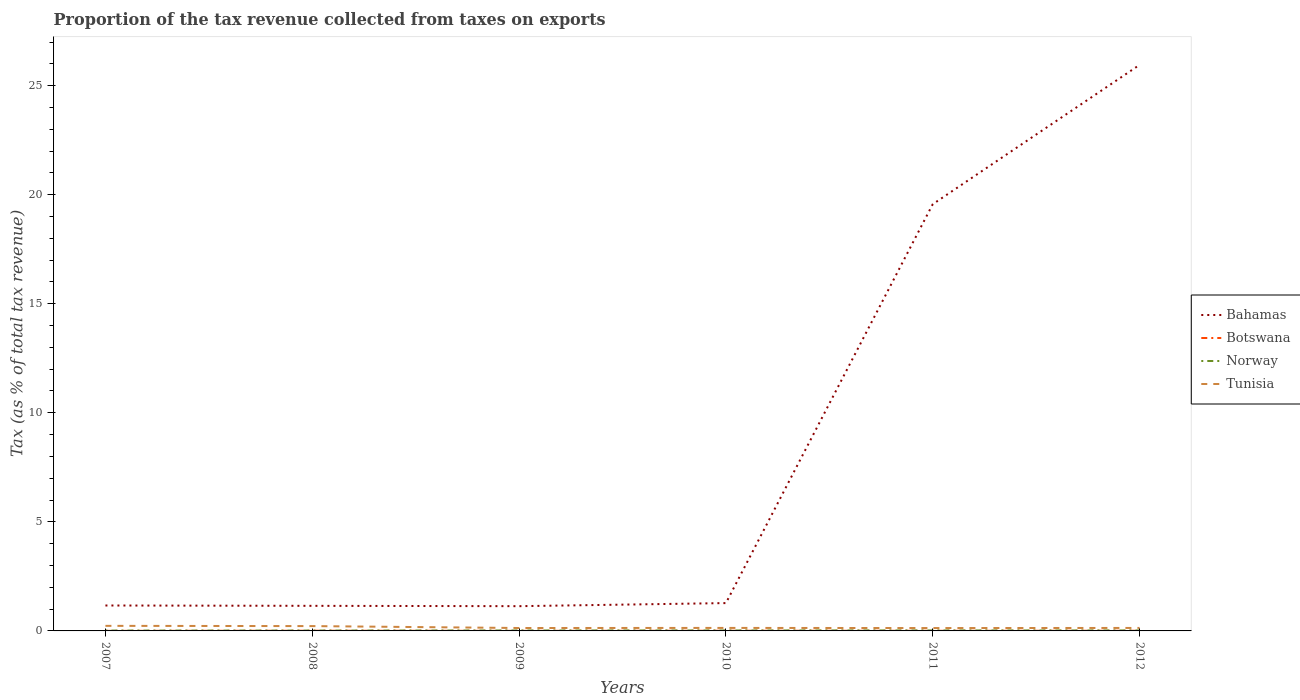Does the line corresponding to Norway intersect with the line corresponding to Bahamas?
Provide a succinct answer. No. Is the number of lines equal to the number of legend labels?
Keep it short and to the point. Yes. Across all years, what is the maximum proportion of the tax revenue collected in Bahamas?
Provide a succinct answer. 1.13. What is the total proportion of the tax revenue collected in Norway in the graph?
Keep it short and to the point. -0. What is the difference between the highest and the second highest proportion of the tax revenue collected in Bahamas?
Give a very brief answer. 24.82. What is the difference between the highest and the lowest proportion of the tax revenue collected in Botswana?
Your answer should be very brief. 3. Is the proportion of the tax revenue collected in Norway strictly greater than the proportion of the tax revenue collected in Botswana over the years?
Ensure brevity in your answer.  No. How many lines are there?
Make the answer very short. 4. Does the graph contain grids?
Make the answer very short. No. Where does the legend appear in the graph?
Your response must be concise. Center right. What is the title of the graph?
Your answer should be very brief. Proportion of the tax revenue collected from taxes on exports. Does "Ireland" appear as one of the legend labels in the graph?
Ensure brevity in your answer.  No. What is the label or title of the Y-axis?
Give a very brief answer. Tax (as % of total tax revenue). What is the Tax (as % of total tax revenue) of Bahamas in 2007?
Provide a succinct answer. 1.17. What is the Tax (as % of total tax revenue) of Botswana in 2007?
Your answer should be very brief. 0. What is the Tax (as % of total tax revenue) of Norway in 2007?
Offer a terse response. 0.02. What is the Tax (as % of total tax revenue) of Tunisia in 2007?
Provide a short and direct response. 0.23. What is the Tax (as % of total tax revenue) in Bahamas in 2008?
Offer a terse response. 1.15. What is the Tax (as % of total tax revenue) of Botswana in 2008?
Ensure brevity in your answer.  0.01. What is the Tax (as % of total tax revenue) in Norway in 2008?
Your answer should be compact. 0.02. What is the Tax (as % of total tax revenue) in Tunisia in 2008?
Provide a succinct answer. 0.22. What is the Tax (as % of total tax revenue) in Bahamas in 2009?
Make the answer very short. 1.13. What is the Tax (as % of total tax revenue) of Botswana in 2009?
Offer a terse response. 0. What is the Tax (as % of total tax revenue) of Norway in 2009?
Give a very brief answer. 0.02. What is the Tax (as % of total tax revenue) of Tunisia in 2009?
Offer a very short reply. 0.13. What is the Tax (as % of total tax revenue) in Bahamas in 2010?
Your answer should be very brief. 1.28. What is the Tax (as % of total tax revenue) of Botswana in 2010?
Provide a succinct answer. 0.01. What is the Tax (as % of total tax revenue) of Norway in 2010?
Ensure brevity in your answer.  0.02. What is the Tax (as % of total tax revenue) of Tunisia in 2010?
Your answer should be very brief. 0.14. What is the Tax (as % of total tax revenue) of Bahamas in 2011?
Ensure brevity in your answer.  19.56. What is the Tax (as % of total tax revenue) in Botswana in 2011?
Provide a short and direct response. 0.01. What is the Tax (as % of total tax revenue) in Norway in 2011?
Keep it short and to the point. 0.02. What is the Tax (as % of total tax revenue) of Tunisia in 2011?
Make the answer very short. 0.13. What is the Tax (as % of total tax revenue) in Bahamas in 2012?
Ensure brevity in your answer.  25.95. What is the Tax (as % of total tax revenue) in Botswana in 2012?
Offer a very short reply. 0.01. What is the Tax (as % of total tax revenue) in Norway in 2012?
Offer a terse response. 0.02. What is the Tax (as % of total tax revenue) of Tunisia in 2012?
Keep it short and to the point. 0.14. Across all years, what is the maximum Tax (as % of total tax revenue) in Bahamas?
Give a very brief answer. 25.95. Across all years, what is the maximum Tax (as % of total tax revenue) in Botswana?
Your response must be concise. 0.01. Across all years, what is the maximum Tax (as % of total tax revenue) of Norway?
Offer a terse response. 0.02. Across all years, what is the maximum Tax (as % of total tax revenue) of Tunisia?
Provide a short and direct response. 0.23. Across all years, what is the minimum Tax (as % of total tax revenue) of Bahamas?
Provide a succinct answer. 1.13. Across all years, what is the minimum Tax (as % of total tax revenue) in Botswana?
Offer a terse response. 0. Across all years, what is the minimum Tax (as % of total tax revenue) of Norway?
Your response must be concise. 0.02. Across all years, what is the minimum Tax (as % of total tax revenue) in Tunisia?
Provide a succinct answer. 0.13. What is the total Tax (as % of total tax revenue) in Bahamas in the graph?
Provide a succinct answer. 50.24. What is the total Tax (as % of total tax revenue) of Botswana in the graph?
Provide a short and direct response. 0.04. What is the total Tax (as % of total tax revenue) in Norway in the graph?
Keep it short and to the point. 0.12. What is the difference between the Tax (as % of total tax revenue) in Bahamas in 2007 and that in 2008?
Offer a very short reply. 0.02. What is the difference between the Tax (as % of total tax revenue) in Botswana in 2007 and that in 2008?
Provide a short and direct response. -0.01. What is the difference between the Tax (as % of total tax revenue) in Norway in 2007 and that in 2008?
Offer a terse response. 0. What is the difference between the Tax (as % of total tax revenue) in Tunisia in 2007 and that in 2008?
Your answer should be compact. 0.01. What is the difference between the Tax (as % of total tax revenue) in Bahamas in 2007 and that in 2009?
Your answer should be compact. 0.03. What is the difference between the Tax (as % of total tax revenue) in Botswana in 2007 and that in 2009?
Provide a short and direct response. -0. What is the difference between the Tax (as % of total tax revenue) in Norway in 2007 and that in 2009?
Your response must be concise. -0. What is the difference between the Tax (as % of total tax revenue) of Tunisia in 2007 and that in 2009?
Offer a very short reply. 0.1. What is the difference between the Tax (as % of total tax revenue) in Bahamas in 2007 and that in 2010?
Your answer should be compact. -0.11. What is the difference between the Tax (as % of total tax revenue) of Botswana in 2007 and that in 2010?
Give a very brief answer. -0.01. What is the difference between the Tax (as % of total tax revenue) in Norway in 2007 and that in 2010?
Ensure brevity in your answer.  -0.01. What is the difference between the Tax (as % of total tax revenue) of Tunisia in 2007 and that in 2010?
Ensure brevity in your answer.  0.09. What is the difference between the Tax (as % of total tax revenue) of Bahamas in 2007 and that in 2011?
Offer a very short reply. -18.4. What is the difference between the Tax (as % of total tax revenue) in Botswana in 2007 and that in 2011?
Provide a succinct answer. -0. What is the difference between the Tax (as % of total tax revenue) of Norway in 2007 and that in 2011?
Give a very brief answer. -0.01. What is the difference between the Tax (as % of total tax revenue) of Tunisia in 2007 and that in 2011?
Your response must be concise. 0.1. What is the difference between the Tax (as % of total tax revenue) of Bahamas in 2007 and that in 2012?
Your response must be concise. -24.79. What is the difference between the Tax (as % of total tax revenue) in Botswana in 2007 and that in 2012?
Your response must be concise. -0.01. What is the difference between the Tax (as % of total tax revenue) in Norway in 2007 and that in 2012?
Your response must be concise. -0. What is the difference between the Tax (as % of total tax revenue) of Tunisia in 2007 and that in 2012?
Ensure brevity in your answer.  0.1. What is the difference between the Tax (as % of total tax revenue) in Bahamas in 2008 and that in 2009?
Your answer should be compact. 0.02. What is the difference between the Tax (as % of total tax revenue) in Botswana in 2008 and that in 2009?
Give a very brief answer. 0. What is the difference between the Tax (as % of total tax revenue) in Norway in 2008 and that in 2009?
Ensure brevity in your answer.  -0. What is the difference between the Tax (as % of total tax revenue) in Tunisia in 2008 and that in 2009?
Your response must be concise. 0.09. What is the difference between the Tax (as % of total tax revenue) of Bahamas in 2008 and that in 2010?
Provide a succinct answer. -0.13. What is the difference between the Tax (as % of total tax revenue) of Botswana in 2008 and that in 2010?
Keep it short and to the point. -0. What is the difference between the Tax (as % of total tax revenue) of Norway in 2008 and that in 2010?
Make the answer very short. -0.01. What is the difference between the Tax (as % of total tax revenue) in Tunisia in 2008 and that in 2010?
Your answer should be very brief. 0.08. What is the difference between the Tax (as % of total tax revenue) in Bahamas in 2008 and that in 2011?
Your response must be concise. -18.41. What is the difference between the Tax (as % of total tax revenue) in Botswana in 2008 and that in 2011?
Provide a succinct answer. 0. What is the difference between the Tax (as % of total tax revenue) in Norway in 2008 and that in 2011?
Your answer should be compact. -0.01. What is the difference between the Tax (as % of total tax revenue) of Tunisia in 2008 and that in 2011?
Provide a succinct answer. 0.09. What is the difference between the Tax (as % of total tax revenue) of Bahamas in 2008 and that in 2012?
Offer a terse response. -24.8. What is the difference between the Tax (as % of total tax revenue) of Botswana in 2008 and that in 2012?
Your answer should be compact. 0. What is the difference between the Tax (as % of total tax revenue) in Norway in 2008 and that in 2012?
Your answer should be very brief. -0. What is the difference between the Tax (as % of total tax revenue) in Tunisia in 2008 and that in 2012?
Your answer should be very brief. 0.09. What is the difference between the Tax (as % of total tax revenue) of Bahamas in 2009 and that in 2010?
Make the answer very short. -0.14. What is the difference between the Tax (as % of total tax revenue) of Botswana in 2009 and that in 2010?
Keep it short and to the point. -0. What is the difference between the Tax (as % of total tax revenue) of Norway in 2009 and that in 2010?
Ensure brevity in your answer.  -0. What is the difference between the Tax (as % of total tax revenue) of Tunisia in 2009 and that in 2010?
Your answer should be very brief. -0. What is the difference between the Tax (as % of total tax revenue) of Bahamas in 2009 and that in 2011?
Make the answer very short. -18.43. What is the difference between the Tax (as % of total tax revenue) of Botswana in 2009 and that in 2011?
Your answer should be compact. -0. What is the difference between the Tax (as % of total tax revenue) of Norway in 2009 and that in 2011?
Make the answer very short. -0. What is the difference between the Tax (as % of total tax revenue) in Tunisia in 2009 and that in 2011?
Provide a short and direct response. 0. What is the difference between the Tax (as % of total tax revenue) in Bahamas in 2009 and that in 2012?
Offer a very short reply. -24.82. What is the difference between the Tax (as % of total tax revenue) in Botswana in 2009 and that in 2012?
Make the answer very short. -0. What is the difference between the Tax (as % of total tax revenue) in Norway in 2009 and that in 2012?
Make the answer very short. -0. What is the difference between the Tax (as % of total tax revenue) of Tunisia in 2009 and that in 2012?
Your answer should be very brief. -0. What is the difference between the Tax (as % of total tax revenue) in Bahamas in 2010 and that in 2011?
Keep it short and to the point. -18.29. What is the difference between the Tax (as % of total tax revenue) in Botswana in 2010 and that in 2011?
Make the answer very short. 0. What is the difference between the Tax (as % of total tax revenue) of Norway in 2010 and that in 2011?
Your answer should be compact. -0. What is the difference between the Tax (as % of total tax revenue) in Tunisia in 2010 and that in 2011?
Make the answer very short. 0.01. What is the difference between the Tax (as % of total tax revenue) in Bahamas in 2010 and that in 2012?
Provide a short and direct response. -24.68. What is the difference between the Tax (as % of total tax revenue) in Botswana in 2010 and that in 2012?
Provide a short and direct response. 0. What is the difference between the Tax (as % of total tax revenue) of Norway in 2010 and that in 2012?
Your response must be concise. 0. What is the difference between the Tax (as % of total tax revenue) of Tunisia in 2010 and that in 2012?
Your answer should be compact. 0. What is the difference between the Tax (as % of total tax revenue) of Bahamas in 2011 and that in 2012?
Your answer should be compact. -6.39. What is the difference between the Tax (as % of total tax revenue) in Botswana in 2011 and that in 2012?
Your response must be concise. -0. What is the difference between the Tax (as % of total tax revenue) of Norway in 2011 and that in 2012?
Make the answer very short. 0. What is the difference between the Tax (as % of total tax revenue) in Tunisia in 2011 and that in 2012?
Your response must be concise. -0. What is the difference between the Tax (as % of total tax revenue) of Bahamas in 2007 and the Tax (as % of total tax revenue) of Botswana in 2008?
Give a very brief answer. 1.16. What is the difference between the Tax (as % of total tax revenue) of Bahamas in 2007 and the Tax (as % of total tax revenue) of Norway in 2008?
Your answer should be compact. 1.15. What is the difference between the Tax (as % of total tax revenue) in Bahamas in 2007 and the Tax (as % of total tax revenue) in Tunisia in 2008?
Ensure brevity in your answer.  0.94. What is the difference between the Tax (as % of total tax revenue) of Botswana in 2007 and the Tax (as % of total tax revenue) of Norway in 2008?
Make the answer very short. -0.01. What is the difference between the Tax (as % of total tax revenue) in Botswana in 2007 and the Tax (as % of total tax revenue) in Tunisia in 2008?
Your answer should be very brief. -0.22. What is the difference between the Tax (as % of total tax revenue) of Norway in 2007 and the Tax (as % of total tax revenue) of Tunisia in 2008?
Your response must be concise. -0.2. What is the difference between the Tax (as % of total tax revenue) of Bahamas in 2007 and the Tax (as % of total tax revenue) of Botswana in 2009?
Provide a short and direct response. 1.16. What is the difference between the Tax (as % of total tax revenue) in Bahamas in 2007 and the Tax (as % of total tax revenue) in Norway in 2009?
Your answer should be compact. 1.15. What is the difference between the Tax (as % of total tax revenue) in Bahamas in 2007 and the Tax (as % of total tax revenue) in Tunisia in 2009?
Offer a very short reply. 1.03. What is the difference between the Tax (as % of total tax revenue) of Botswana in 2007 and the Tax (as % of total tax revenue) of Norway in 2009?
Offer a very short reply. -0.02. What is the difference between the Tax (as % of total tax revenue) in Botswana in 2007 and the Tax (as % of total tax revenue) in Tunisia in 2009?
Your answer should be very brief. -0.13. What is the difference between the Tax (as % of total tax revenue) of Norway in 2007 and the Tax (as % of total tax revenue) of Tunisia in 2009?
Offer a terse response. -0.12. What is the difference between the Tax (as % of total tax revenue) of Bahamas in 2007 and the Tax (as % of total tax revenue) of Botswana in 2010?
Offer a terse response. 1.16. What is the difference between the Tax (as % of total tax revenue) in Bahamas in 2007 and the Tax (as % of total tax revenue) in Norway in 2010?
Make the answer very short. 1.14. What is the difference between the Tax (as % of total tax revenue) of Bahamas in 2007 and the Tax (as % of total tax revenue) of Tunisia in 2010?
Give a very brief answer. 1.03. What is the difference between the Tax (as % of total tax revenue) of Botswana in 2007 and the Tax (as % of total tax revenue) of Norway in 2010?
Keep it short and to the point. -0.02. What is the difference between the Tax (as % of total tax revenue) of Botswana in 2007 and the Tax (as % of total tax revenue) of Tunisia in 2010?
Give a very brief answer. -0.14. What is the difference between the Tax (as % of total tax revenue) in Norway in 2007 and the Tax (as % of total tax revenue) in Tunisia in 2010?
Your answer should be very brief. -0.12. What is the difference between the Tax (as % of total tax revenue) in Bahamas in 2007 and the Tax (as % of total tax revenue) in Botswana in 2011?
Provide a succinct answer. 1.16. What is the difference between the Tax (as % of total tax revenue) of Bahamas in 2007 and the Tax (as % of total tax revenue) of Norway in 2011?
Give a very brief answer. 1.14. What is the difference between the Tax (as % of total tax revenue) of Bahamas in 2007 and the Tax (as % of total tax revenue) of Tunisia in 2011?
Offer a very short reply. 1.03. What is the difference between the Tax (as % of total tax revenue) of Botswana in 2007 and the Tax (as % of total tax revenue) of Norway in 2011?
Your answer should be compact. -0.02. What is the difference between the Tax (as % of total tax revenue) in Botswana in 2007 and the Tax (as % of total tax revenue) in Tunisia in 2011?
Offer a very short reply. -0.13. What is the difference between the Tax (as % of total tax revenue) of Norway in 2007 and the Tax (as % of total tax revenue) of Tunisia in 2011?
Provide a short and direct response. -0.12. What is the difference between the Tax (as % of total tax revenue) of Bahamas in 2007 and the Tax (as % of total tax revenue) of Botswana in 2012?
Provide a short and direct response. 1.16. What is the difference between the Tax (as % of total tax revenue) of Bahamas in 2007 and the Tax (as % of total tax revenue) of Norway in 2012?
Make the answer very short. 1.14. What is the difference between the Tax (as % of total tax revenue) in Bahamas in 2007 and the Tax (as % of total tax revenue) in Tunisia in 2012?
Offer a terse response. 1.03. What is the difference between the Tax (as % of total tax revenue) of Botswana in 2007 and the Tax (as % of total tax revenue) of Norway in 2012?
Your answer should be very brief. -0.02. What is the difference between the Tax (as % of total tax revenue) of Botswana in 2007 and the Tax (as % of total tax revenue) of Tunisia in 2012?
Provide a succinct answer. -0.13. What is the difference between the Tax (as % of total tax revenue) in Norway in 2007 and the Tax (as % of total tax revenue) in Tunisia in 2012?
Your response must be concise. -0.12. What is the difference between the Tax (as % of total tax revenue) of Bahamas in 2008 and the Tax (as % of total tax revenue) of Botswana in 2009?
Offer a very short reply. 1.15. What is the difference between the Tax (as % of total tax revenue) in Bahamas in 2008 and the Tax (as % of total tax revenue) in Norway in 2009?
Offer a terse response. 1.13. What is the difference between the Tax (as % of total tax revenue) of Bahamas in 2008 and the Tax (as % of total tax revenue) of Tunisia in 2009?
Provide a short and direct response. 1.02. What is the difference between the Tax (as % of total tax revenue) of Botswana in 2008 and the Tax (as % of total tax revenue) of Norway in 2009?
Your response must be concise. -0.01. What is the difference between the Tax (as % of total tax revenue) in Botswana in 2008 and the Tax (as % of total tax revenue) in Tunisia in 2009?
Provide a succinct answer. -0.13. What is the difference between the Tax (as % of total tax revenue) of Norway in 2008 and the Tax (as % of total tax revenue) of Tunisia in 2009?
Provide a short and direct response. -0.12. What is the difference between the Tax (as % of total tax revenue) in Bahamas in 2008 and the Tax (as % of total tax revenue) in Botswana in 2010?
Ensure brevity in your answer.  1.14. What is the difference between the Tax (as % of total tax revenue) in Bahamas in 2008 and the Tax (as % of total tax revenue) in Norway in 2010?
Provide a short and direct response. 1.13. What is the difference between the Tax (as % of total tax revenue) in Bahamas in 2008 and the Tax (as % of total tax revenue) in Tunisia in 2010?
Make the answer very short. 1.01. What is the difference between the Tax (as % of total tax revenue) of Botswana in 2008 and the Tax (as % of total tax revenue) of Norway in 2010?
Make the answer very short. -0.01. What is the difference between the Tax (as % of total tax revenue) in Botswana in 2008 and the Tax (as % of total tax revenue) in Tunisia in 2010?
Provide a short and direct response. -0.13. What is the difference between the Tax (as % of total tax revenue) of Norway in 2008 and the Tax (as % of total tax revenue) of Tunisia in 2010?
Provide a succinct answer. -0.12. What is the difference between the Tax (as % of total tax revenue) of Bahamas in 2008 and the Tax (as % of total tax revenue) of Botswana in 2011?
Provide a short and direct response. 1.14. What is the difference between the Tax (as % of total tax revenue) in Bahamas in 2008 and the Tax (as % of total tax revenue) in Norway in 2011?
Give a very brief answer. 1.13. What is the difference between the Tax (as % of total tax revenue) in Bahamas in 2008 and the Tax (as % of total tax revenue) in Tunisia in 2011?
Make the answer very short. 1.02. What is the difference between the Tax (as % of total tax revenue) in Botswana in 2008 and the Tax (as % of total tax revenue) in Norway in 2011?
Ensure brevity in your answer.  -0.01. What is the difference between the Tax (as % of total tax revenue) in Botswana in 2008 and the Tax (as % of total tax revenue) in Tunisia in 2011?
Keep it short and to the point. -0.12. What is the difference between the Tax (as % of total tax revenue) in Norway in 2008 and the Tax (as % of total tax revenue) in Tunisia in 2011?
Give a very brief answer. -0.12. What is the difference between the Tax (as % of total tax revenue) in Bahamas in 2008 and the Tax (as % of total tax revenue) in Botswana in 2012?
Your response must be concise. 1.14. What is the difference between the Tax (as % of total tax revenue) in Bahamas in 2008 and the Tax (as % of total tax revenue) in Norway in 2012?
Your answer should be compact. 1.13. What is the difference between the Tax (as % of total tax revenue) in Bahamas in 2008 and the Tax (as % of total tax revenue) in Tunisia in 2012?
Offer a terse response. 1.01. What is the difference between the Tax (as % of total tax revenue) in Botswana in 2008 and the Tax (as % of total tax revenue) in Norway in 2012?
Give a very brief answer. -0.01. What is the difference between the Tax (as % of total tax revenue) of Botswana in 2008 and the Tax (as % of total tax revenue) of Tunisia in 2012?
Offer a very short reply. -0.13. What is the difference between the Tax (as % of total tax revenue) of Norway in 2008 and the Tax (as % of total tax revenue) of Tunisia in 2012?
Make the answer very short. -0.12. What is the difference between the Tax (as % of total tax revenue) of Bahamas in 2009 and the Tax (as % of total tax revenue) of Botswana in 2010?
Your answer should be compact. 1.13. What is the difference between the Tax (as % of total tax revenue) in Bahamas in 2009 and the Tax (as % of total tax revenue) in Norway in 2010?
Offer a terse response. 1.11. What is the difference between the Tax (as % of total tax revenue) of Bahamas in 2009 and the Tax (as % of total tax revenue) of Tunisia in 2010?
Offer a very short reply. 1. What is the difference between the Tax (as % of total tax revenue) in Botswana in 2009 and the Tax (as % of total tax revenue) in Norway in 2010?
Ensure brevity in your answer.  -0.02. What is the difference between the Tax (as % of total tax revenue) in Botswana in 2009 and the Tax (as % of total tax revenue) in Tunisia in 2010?
Make the answer very short. -0.13. What is the difference between the Tax (as % of total tax revenue) of Norway in 2009 and the Tax (as % of total tax revenue) of Tunisia in 2010?
Make the answer very short. -0.12. What is the difference between the Tax (as % of total tax revenue) of Bahamas in 2009 and the Tax (as % of total tax revenue) of Botswana in 2011?
Offer a very short reply. 1.13. What is the difference between the Tax (as % of total tax revenue) in Bahamas in 2009 and the Tax (as % of total tax revenue) in Norway in 2011?
Offer a very short reply. 1.11. What is the difference between the Tax (as % of total tax revenue) in Botswana in 2009 and the Tax (as % of total tax revenue) in Norway in 2011?
Keep it short and to the point. -0.02. What is the difference between the Tax (as % of total tax revenue) in Botswana in 2009 and the Tax (as % of total tax revenue) in Tunisia in 2011?
Your response must be concise. -0.13. What is the difference between the Tax (as % of total tax revenue) in Norway in 2009 and the Tax (as % of total tax revenue) in Tunisia in 2011?
Ensure brevity in your answer.  -0.11. What is the difference between the Tax (as % of total tax revenue) of Bahamas in 2009 and the Tax (as % of total tax revenue) of Botswana in 2012?
Provide a succinct answer. 1.13. What is the difference between the Tax (as % of total tax revenue) in Bahamas in 2009 and the Tax (as % of total tax revenue) in Norway in 2012?
Your answer should be compact. 1.11. What is the difference between the Tax (as % of total tax revenue) of Bahamas in 2009 and the Tax (as % of total tax revenue) of Tunisia in 2012?
Keep it short and to the point. 1. What is the difference between the Tax (as % of total tax revenue) of Botswana in 2009 and the Tax (as % of total tax revenue) of Norway in 2012?
Offer a very short reply. -0.02. What is the difference between the Tax (as % of total tax revenue) of Botswana in 2009 and the Tax (as % of total tax revenue) of Tunisia in 2012?
Give a very brief answer. -0.13. What is the difference between the Tax (as % of total tax revenue) of Norway in 2009 and the Tax (as % of total tax revenue) of Tunisia in 2012?
Provide a short and direct response. -0.12. What is the difference between the Tax (as % of total tax revenue) in Bahamas in 2010 and the Tax (as % of total tax revenue) in Botswana in 2011?
Give a very brief answer. 1.27. What is the difference between the Tax (as % of total tax revenue) in Bahamas in 2010 and the Tax (as % of total tax revenue) in Norway in 2011?
Provide a succinct answer. 1.25. What is the difference between the Tax (as % of total tax revenue) in Bahamas in 2010 and the Tax (as % of total tax revenue) in Tunisia in 2011?
Make the answer very short. 1.14. What is the difference between the Tax (as % of total tax revenue) of Botswana in 2010 and the Tax (as % of total tax revenue) of Norway in 2011?
Your response must be concise. -0.01. What is the difference between the Tax (as % of total tax revenue) in Botswana in 2010 and the Tax (as % of total tax revenue) in Tunisia in 2011?
Ensure brevity in your answer.  -0.12. What is the difference between the Tax (as % of total tax revenue) in Norway in 2010 and the Tax (as % of total tax revenue) in Tunisia in 2011?
Offer a very short reply. -0.11. What is the difference between the Tax (as % of total tax revenue) of Bahamas in 2010 and the Tax (as % of total tax revenue) of Botswana in 2012?
Offer a terse response. 1.27. What is the difference between the Tax (as % of total tax revenue) in Bahamas in 2010 and the Tax (as % of total tax revenue) in Norway in 2012?
Your response must be concise. 1.25. What is the difference between the Tax (as % of total tax revenue) in Bahamas in 2010 and the Tax (as % of total tax revenue) in Tunisia in 2012?
Your answer should be very brief. 1.14. What is the difference between the Tax (as % of total tax revenue) of Botswana in 2010 and the Tax (as % of total tax revenue) of Norway in 2012?
Your answer should be compact. -0.01. What is the difference between the Tax (as % of total tax revenue) in Botswana in 2010 and the Tax (as % of total tax revenue) in Tunisia in 2012?
Ensure brevity in your answer.  -0.13. What is the difference between the Tax (as % of total tax revenue) in Norway in 2010 and the Tax (as % of total tax revenue) in Tunisia in 2012?
Your answer should be compact. -0.11. What is the difference between the Tax (as % of total tax revenue) of Bahamas in 2011 and the Tax (as % of total tax revenue) of Botswana in 2012?
Offer a very short reply. 19.56. What is the difference between the Tax (as % of total tax revenue) in Bahamas in 2011 and the Tax (as % of total tax revenue) in Norway in 2012?
Ensure brevity in your answer.  19.54. What is the difference between the Tax (as % of total tax revenue) of Bahamas in 2011 and the Tax (as % of total tax revenue) of Tunisia in 2012?
Give a very brief answer. 19.43. What is the difference between the Tax (as % of total tax revenue) in Botswana in 2011 and the Tax (as % of total tax revenue) in Norway in 2012?
Ensure brevity in your answer.  -0.02. What is the difference between the Tax (as % of total tax revenue) in Botswana in 2011 and the Tax (as % of total tax revenue) in Tunisia in 2012?
Give a very brief answer. -0.13. What is the difference between the Tax (as % of total tax revenue) in Norway in 2011 and the Tax (as % of total tax revenue) in Tunisia in 2012?
Provide a short and direct response. -0.11. What is the average Tax (as % of total tax revenue) of Bahamas per year?
Give a very brief answer. 8.37. What is the average Tax (as % of total tax revenue) in Botswana per year?
Make the answer very short. 0.01. What is the average Tax (as % of total tax revenue) in Norway per year?
Your response must be concise. 0.02. What is the average Tax (as % of total tax revenue) of Tunisia per year?
Ensure brevity in your answer.  0.17. In the year 2007, what is the difference between the Tax (as % of total tax revenue) of Bahamas and Tax (as % of total tax revenue) of Botswana?
Provide a short and direct response. 1.16. In the year 2007, what is the difference between the Tax (as % of total tax revenue) of Bahamas and Tax (as % of total tax revenue) of Norway?
Your answer should be very brief. 1.15. In the year 2007, what is the difference between the Tax (as % of total tax revenue) in Bahamas and Tax (as % of total tax revenue) in Tunisia?
Your answer should be very brief. 0.93. In the year 2007, what is the difference between the Tax (as % of total tax revenue) of Botswana and Tax (as % of total tax revenue) of Norway?
Give a very brief answer. -0.01. In the year 2007, what is the difference between the Tax (as % of total tax revenue) of Botswana and Tax (as % of total tax revenue) of Tunisia?
Ensure brevity in your answer.  -0.23. In the year 2007, what is the difference between the Tax (as % of total tax revenue) of Norway and Tax (as % of total tax revenue) of Tunisia?
Give a very brief answer. -0.22. In the year 2008, what is the difference between the Tax (as % of total tax revenue) of Bahamas and Tax (as % of total tax revenue) of Botswana?
Provide a succinct answer. 1.14. In the year 2008, what is the difference between the Tax (as % of total tax revenue) in Bahamas and Tax (as % of total tax revenue) in Norway?
Keep it short and to the point. 1.13. In the year 2008, what is the difference between the Tax (as % of total tax revenue) of Bahamas and Tax (as % of total tax revenue) of Tunisia?
Offer a terse response. 0.93. In the year 2008, what is the difference between the Tax (as % of total tax revenue) in Botswana and Tax (as % of total tax revenue) in Norway?
Your answer should be compact. -0.01. In the year 2008, what is the difference between the Tax (as % of total tax revenue) in Botswana and Tax (as % of total tax revenue) in Tunisia?
Your response must be concise. -0.21. In the year 2008, what is the difference between the Tax (as % of total tax revenue) of Norway and Tax (as % of total tax revenue) of Tunisia?
Provide a short and direct response. -0.2. In the year 2009, what is the difference between the Tax (as % of total tax revenue) of Bahamas and Tax (as % of total tax revenue) of Botswana?
Your answer should be compact. 1.13. In the year 2009, what is the difference between the Tax (as % of total tax revenue) of Bahamas and Tax (as % of total tax revenue) of Norway?
Provide a succinct answer. 1.11. In the year 2009, what is the difference between the Tax (as % of total tax revenue) in Botswana and Tax (as % of total tax revenue) in Norway?
Offer a terse response. -0.02. In the year 2009, what is the difference between the Tax (as % of total tax revenue) in Botswana and Tax (as % of total tax revenue) in Tunisia?
Make the answer very short. -0.13. In the year 2009, what is the difference between the Tax (as % of total tax revenue) of Norway and Tax (as % of total tax revenue) of Tunisia?
Make the answer very short. -0.11. In the year 2010, what is the difference between the Tax (as % of total tax revenue) in Bahamas and Tax (as % of total tax revenue) in Botswana?
Provide a succinct answer. 1.27. In the year 2010, what is the difference between the Tax (as % of total tax revenue) in Bahamas and Tax (as % of total tax revenue) in Norway?
Make the answer very short. 1.25. In the year 2010, what is the difference between the Tax (as % of total tax revenue) in Bahamas and Tax (as % of total tax revenue) in Tunisia?
Provide a succinct answer. 1.14. In the year 2010, what is the difference between the Tax (as % of total tax revenue) of Botswana and Tax (as % of total tax revenue) of Norway?
Your answer should be compact. -0.01. In the year 2010, what is the difference between the Tax (as % of total tax revenue) in Botswana and Tax (as % of total tax revenue) in Tunisia?
Offer a terse response. -0.13. In the year 2010, what is the difference between the Tax (as % of total tax revenue) in Norway and Tax (as % of total tax revenue) in Tunisia?
Your answer should be very brief. -0.12. In the year 2011, what is the difference between the Tax (as % of total tax revenue) in Bahamas and Tax (as % of total tax revenue) in Botswana?
Provide a short and direct response. 19.56. In the year 2011, what is the difference between the Tax (as % of total tax revenue) in Bahamas and Tax (as % of total tax revenue) in Norway?
Offer a very short reply. 19.54. In the year 2011, what is the difference between the Tax (as % of total tax revenue) in Bahamas and Tax (as % of total tax revenue) in Tunisia?
Your answer should be compact. 19.43. In the year 2011, what is the difference between the Tax (as % of total tax revenue) of Botswana and Tax (as % of total tax revenue) of Norway?
Make the answer very short. -0.02. In the year 2011, what is the difference between the Tax (as % of total tax revenue) in Botswana and Tax (as % of total tax revenue) in Tunisia?
Make the answer very short. -0.13. In the year 2011, what is the difference between the Tax (as % of total tax revenue) in Norway and Tax (as % of total tax revenue) in Tunisia?
Your response must be concise. -0.11. In the year 2012, what is the difference between the Tax (as % of total tax revenue) in Bahamas and Tax (as % of total tax revenue) in Botswana?
Offer a very short reply. 25.94. In the year 2012, what is the difference between the Tax (as % of total tax revenue) in Bahamas and Tax (as % of total tax revenue) in Norway?
Your answer should be compact. 25.93. In the year 2012, what is the difference between the Tax (as % of total tax revenue) of Bahamas and Tax (as % of total tax revenue) of Tunisia?
Make the answer very short. 25.82. In the year 2012, what is the difference between the Tax (as % of total tax revenue) of Botswana and Tax (as % of total tax revenue) of Norway?
Give a very brief answer. -0.01. In the year 2012, what is the difference between the Tax (as % of total tax revenue) in Botswana and Tax (as % of total tax revenue) in Tunisia?
Offer a terse response. -0.13. In the year 2012, what is the difference between the Tax (as % of total tax revenue) of Norway and Tax (as % of total tax revenue) of Tunisia?
Your answer should be compact. -0.12. What is the ratio of the Tax (as % of total tax revenue) in Bahamas in 2007 to that in 2008?
Offer a very short reply. 1.01. What is the ratio of the Tax (as % of total tax revenue) in Botswana in 2007 to that in 2008?
Offer a terse response. 0.32. What is the ratio of the Tax (as % of total tax revenue) in Tunisia in 2007 to that in 2008?
Keep it short and to the point. 1.05. What is the ratio of the Tax (as % of total tax revenue) of Bahamas in 2007 to that in 2009?
Provide a short and direct response. 1.03. What is the ratio of the Tax (as % of total tax revenue) in Botswana in 2007 to that in 2009?
Ensure brevity in your answer.  0.72. What is the ratio of the Tax (as % of total tax revenue) of Norway in 2007 to that in 2009?
Ensure brevity in your answer.  0.8. What is the ratio of the Tax (as % of total tax revenue) in Tunisia in 2007 to that in 2009?
Your response must be concise. 1.74. What is the ratio of the Tax (as % of total tax revenue) of Bahamas in 2007 to that in 2010?
Offer a terse response. 0.91. What is the ratio of the Tax (as % of total tax revenue) in Botswana in 2007 to that in 2010?
Offer a very short reply. 0.31. What is the ratio of the Tax (as % of total tax revenue) of Norway in 2007 to that in 2010?
Ensure brevity in your answer.  0.77. What is the ratio of the Tax (as % of total tax revenue) of Tunisia in 2007 to that in 2010?
Your answer should be compact. 1.69. What is the ratio of the Tax (as % of total tax revenue) of Bahamas in 2007 to that in 2011?
Your answer should be compact. 0.06. What is the ratio of the Tax (as % of total tax revenue) of Botswana in 2007 to that in 2011?
Your response must be concise. 0.47. What is the ratio of the Tax (as % of total tax revenue) of Norway in 2007 to that in 2011?
Provide a succinct answer. 0.75. What is the ratio of the Tax (as % of total tax revenue) in Tunisia in 2007 to that in 2011?
Provide a succinct answer. 1.76. What is the ratio of the Tax (as % of total tax revenue) in Bahamas in 2007 to that in 2012?
Give a very brief answer. 0.04. What is the ratio of the Tax (as % of total tax revenue) of Botswana in 2007 to that in 2012?
Offer a terse response. 0.34. What is the ratio of the Tax (as % of total tax revenue) of Norway in 2007 to that in 2012?
Ensure brevity in your answer.  0.78. What is the ratio of the Tax (as % of total tax revenue) of Tunisia in 2007 to that in 2012?
Provide a succinct answer. 1.7. What is the ratio of the Tax (as % of total tax revenue) of Bahamas in 2008 to that in 2009?
Keep it short and to the point. 1.01. What is the ratio of the Tax (as % of total tax revenue) in Botswana in 2008 to that in 2009?
Provide a short and direct response. 2.28. What is the ratio of the Tax (as % of total tax revenue) of Norway in 2008 to that in 2009?
Provide a short and direct response. 0.8. What is the ratio of the Tax (as % of total tax revenue) in Tunisia in 2008 to that in 2009?
Make the answer very short. 1.66. What is the ratio of the Tax (as % of total tax revenue) in Bahamas in 2008 to that in 2010?
Your answer should be very brief. 0.9. What is the ratio of the Tax (as % of total tax revenue) in Botswana in 2008 to that in 2010?
Make the answer very short. 0.98. What is the ratio of the Tax (as % of total tax revenue) in Norway in 2008 to that in 2010?
Keep it short and to the point. 0.77. What is the ratio of the Tax (as % of total tax revenue) in Tunisia in 2008 to that in 2010?
Provide a short and direct response. 1.61. What is the ratio of the Tax (as % of total tax revenue) of Bahamas in 2008 to that in 2011?
Give a very brief answer. 0.06. What is the ratio of the Tax (as % of total tax revenue) of Botswana in 2008 to that in 2011?
Ensure brevity in your answer.  1.47. What is the ratio of the Tax (as % of total tax revenue) of Norway in 2008 to that in 2011?
Your response must be concise. 0.75. What is the ratio of the Tax (as % of total tax revenue) of Tunisia in 2008 to that in 2011?
Your answer should be compact. 1.68. What is the ratio of the Tax (as % of total tax revenue) in Bahamas in 2008 to that in 2012?
Make the answer very short. 0.04. What is the ratio of the Tax (as % of total tax revenue) in Botswana in 2008 to that in 2012?
Provide a short and direct response. 1.07. What is the ratio of the Tax (as % of total tax revenue) of Norway in 2008 to that in 2012?
Keep it short and to the point. 0.77. What is the ratio of the Tax (as % of total tax revenue) in Tunisia in 2008 to that in 2012?
Offer a terse response. 1.62. What is the ratio of the Tax (as % of total tax revenue) in Bahamas in 2009 to that in 2010?
Provide a succinct answer. 0.89. What is the ratio of the Tax (as % of total tax revenue) in Botswana in 2009 to that in 2010?
Your answer should be compact. 0.43. What is the ratio of the Tax (as % of total tax revenue) in Norway in 2009 to that in 2010?
Ensure brevity in your answer.  0.96. What is the ratio of the Tax (as % of total tax revenue) of Tunisia in 2009 to that in 2010?
Provide a succinct answer. 0.97. What is the ratio of the Tax (as % of total tax revenue) in Bahamas in 2009 to that in 2011?
Your response must be concise. 0.06. What is the ratio of the Tax (as % of total tax revenue) in Botswana in 2009 to that in 2011?
Offer a very short reply. 0.65. What is the ratio of the Tax (as % of total tax revenue) in Norway in 2009 to that in 2011?
Give a very brief answer. 0.93. What is the ratio of the Tax (as % of total tax revenue) in Tunisia in 2009 to that in 2011?
Make the answer very short. 1.01. What is the ratio of the Tax (as % of total tax revenue) in Bahamas in 2009 to that in 2012?
Give a very brief answer. 0.04. What is the ratio of the Tax (as % of total tax revenue) of Botswana in 2009 to that in 2012?
Make the answer very short. 0.47. What is the ratio of the Tax (as % of total tax revenue) of Norway in 2009 to that in 2012?
Your answer should be compact. 0.97. What is the ratio of the Tax (as % of total tax revenue) in Tunisia in 2009 to that in 2012?
Your answer should be compact. 0.98. What is the ratio of the Tax (as % of total tax revenue) of Bahamas in 2010 to that in 2011?
Give a very brief answer. 0.07. What is the ratio of the Tax (as % of total tax revenue) of Botswana in 2010 to that in 2011?
Offer a very short reply. 1.51. What is the ratio of the Tax (as % of total tax revenue) in Norway in 2010 to that in 2011?
Ensure brevity in your answer.  0.97. What is the ratio of the Tax (as % of total tax revenue) in Tunisia in 2010 to that in 2011?
Your answer should be very brief. 1.05. What is the ratio of the Tax (as % of total tax revenue) in Bahamas in 2010 to that in 2012?
Your response must be concise. 0.05. What is the ratio of the Tax (as % of total tax revenue) in Botswana in 2010 to that in 2012?
Offer a terse response. 1.1. What is the ratio of the Tax (as % of total tax revenue) in Norway in 2010 to that in 2012?
Keep it short and to the point. 1.01. What is the ratio of the Tax (as % of total tax revenue) of Tunisia in 2010 to that in 2012?
Ensure brevity in your answer.  1.01. What is the ratio of the Tax (as % of total tax revenue) of Bahamas in 2011 to that in 2012?
Ensure brevity in your answer.  0.75. What is the ratio of the Tax (as % of total tax revenue) of Botswana in 2011 to that in 2012?
Offer a terse response. 0.73. What is the ratio of the Tax (as % of total tax revenue) in Norway in 2011 to that in 2012?
Keep it short and to the point. 1.04. What is the ratio of the Tax (as % of total tax revenue) of Tunisia in 2011 to that in 2012?
Provide a succinct answer. 0.96. What is the difference between the highest and the second highest Tax (as % of total tax revenue) of Bahamas?
Provide a succinct answer. 6.39. What is the difference between the highest and the second highest Tax (as % of total tax revenue) of Norway?
Make the answer very short. 0. What is the difference between the highest and the second highest Tax (as % of total tax revenue) of Tunisia?
Provide a succinct answer. 0.01. What is the difference between the highest and the lowest Tax (as % of total tax revenue) of Bahamas?
Offer a terse response. 24.82. What is the difference between the highest and the lowest Tax (as % of total tax revenue) of Botswana?
Ensure brevity in your answer.  0.01. What is the difference between the highest and the lowest Tax (as % of total tax revenue) in Norway?
Your answer should be very brief. 0.01. What is the difference between the highest and the lowest Tax (as % of total tax revenue) of Tunisia?
Your response must be concise. 0.1. 